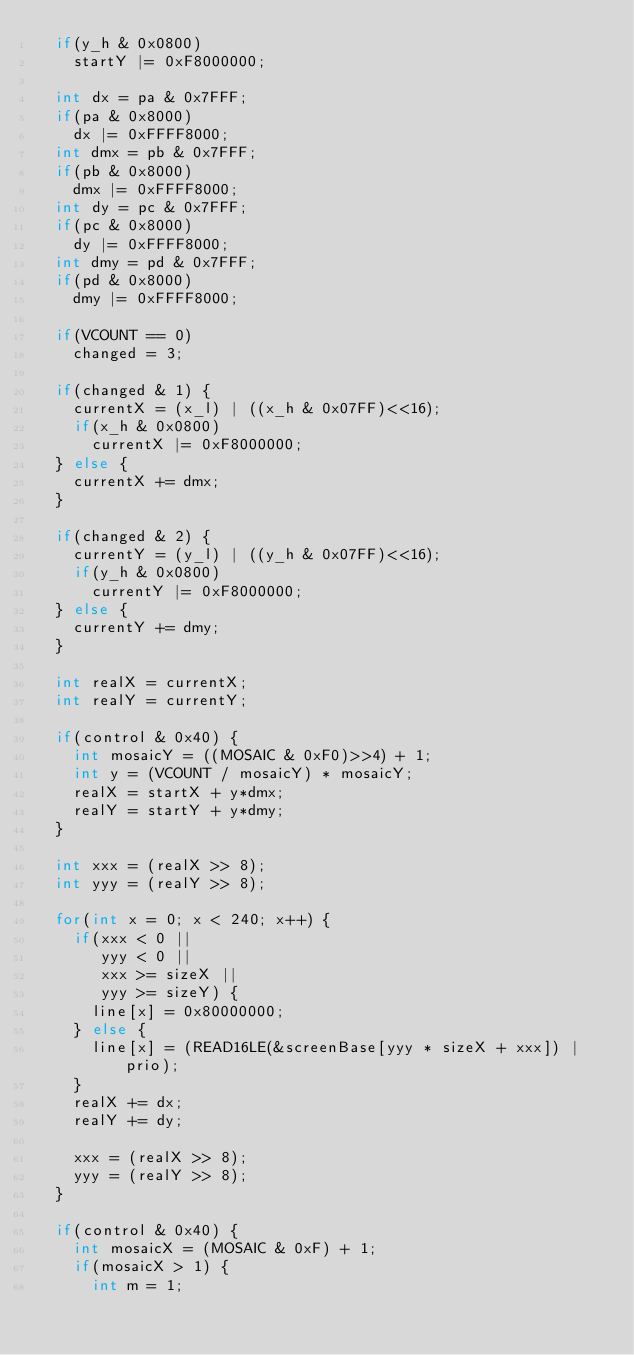Convert code to text. <code><loc_0><loc_0><loc_500><loc_500><_C++_>  if(y_h & 0x0800)
    startY |= 0xF8000000;

  int dx = pa & 0x7FFF;
  if(pa & 0x8000)
    dx |= 0xFFFF8000;
  int dmx = pb & 0x7FFF;
  if(pb & 0x8000)
    dmx |= 0xFFFF8000;
  int dy = pc & 0x7FFF;
  if(pc & 0x8000)
    dy |= 0xFFFF8000;
  int dmy = pd & 0x7FFF;
  if(pd & 0x8000)
    dmy |= 0xFFFF8000;

  if(VCOUNT == 0)
    changed = 3;

  if(changed & 1) {
    currentX = (x_l) | ((x_h & 0x07FF)<<16);
    if(x_h & 0x0800)
      currentX |= 0xF8000000;
  } else {
    currentX += dmx;
  }

  if(changed & 2) {
    currentY = (y_l) | ((y_h & 0x07FF)<<16);
    if(y_h & 0x0800)
      currentY |= 0xF8000000;
  } else {
    currentY += dmy;
  }  
  
  int realX = currentX;
  int realY = currentY;

  if(control & 0x40) {
    int mosaicY = ((MOSAIC & 0xF0)>>4) + 1;
    int y = (VCOUNT / mosaicY) * mosaicY;
    realX = startX + y*dmx;
    realY = startY + y*dmy;
  }
  
  int xxx = (realX >> 8);
  int yyy = (realY >> 8);
  
  for(int x = 0; x < 240; x++) {
    if(xxx < 0 ||
       yyy < 0 ||
       xxx >= sizeX ||
       yyy >= sizeY) {
      line[x] = 0x80000000;
    } else {
      line[x] = (READ16LE(&screenBase[yyy * sizeX + xxx]) | prio);
    }
    realX += dx;
    realY += dy;
    
    xxx = (realX >> 8);
    yyy = (realY >> 8);
  }

  if(control & 0x40) {    
    int mosaicX = (MOSAIC & 0xF) + 1;
    if(mosaicX > 1) {
      int m = 1;</code> 